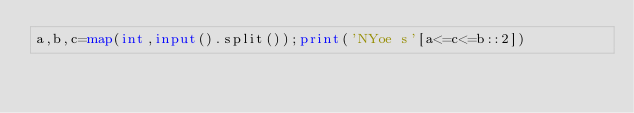<code> <loc_0><loc_0><loc_500><loc_500><_Python_>a,b,c=map(int,input().split());print('NYoe s'[a<=c<=b::2])</code> 